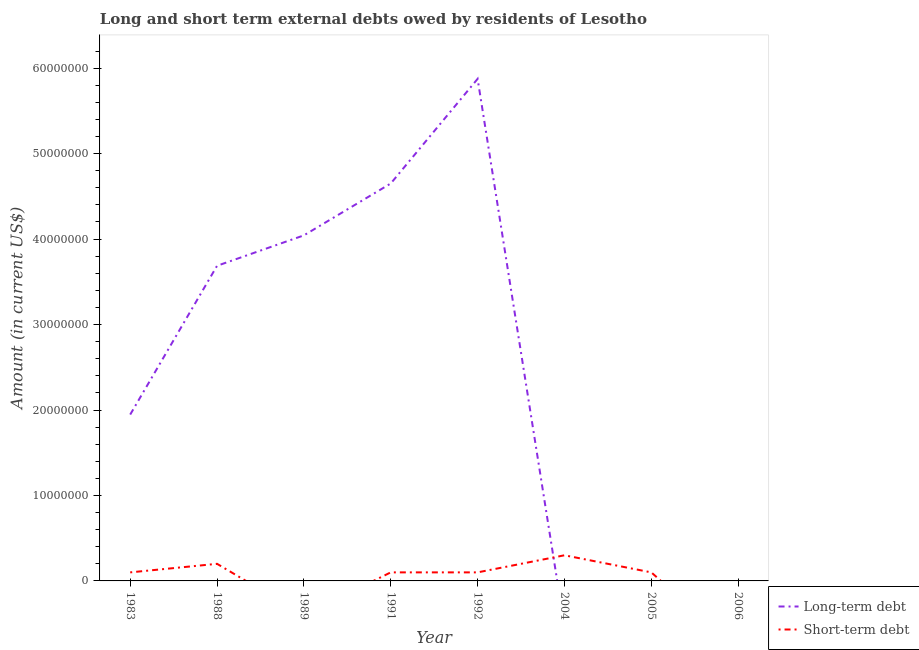How many different coloured lines are there?
Provide a succinct answer. 2. What is the short-term debts owed by residents in 1991?
Make the answer very short. 1.00e+06. Across all years, what is the maximum long-term debts owed by residents?
Your response must be concise. 5.87e+07. Across all years, what is the minimum short-term debts owed by residents?
Provide a short and direct response. 0. What is the total short-term debts owed by residents in the graph?
Ensure brevity in your answer.  9.00e+06. What is the difference between the long-term debts owed by residents in 1989 and that in 1991?
Provide a short and direct response. -6.07e+06. What is the difference between the short-term debts owed by residents in 2005 and the long-term debts owed by residents in 1992?
Keep it short and to the point. -5.77e+07. What is the average short-term debts owed by residents per year?
Your response must be concise. 1.12e+06. In the year 1991, what is the difference between the short-term debts owed by residents and long-term debts owed by residents?
Offer a very short reply. -4.55e+07. In how many years, is the long-term debts owed by residents greater than 24000000 US$?
Your answer should be compact. 4. What is the ratio of the short-term debts owed by residents in 1988 to that in 2004?
Give a very brief answer. 0.67. What is the difference between the highest and the second highest long-term debts owed by residents?
Give a very brief answer. 1.22e+07. What is the difference between the highest and the lowest short-term debts owed by residents?
Ensure brevity in your answer.  3.00e+06. In how many years, is the long-term debts owed by residents greater than the average long-term debts owed by residents taken over all years?
Give a very brief answer. 4. Is the sum of the short-term debts owed by residents in 1991 and 1992 greater than the maximum long-term debts owed by residents across all years?
Make the answer very short. No. How many lines are there?
Keep it short and to the point. 2. How many years are there in the graph?
Provide a succinct answer. 8. What is the difference between two consecutive major ticks on the Y-axis?
Your answer should be very brief. 1.00e+07. Are the values on the major ticks of Y-axis written in scientific E-notation?
Your answer should be very brief. No. Does the graph contain any zero values?
Give a very brief answer. Yes. Where does the legend appear in the graph?
Your answer should be very brief. Bottom right. How many legend labels are there?
Provide a succinct answer. 2. How are the legend labels stacked?
Give a very brief answer. Vertical. What is the title of the graph?
Make the answer very short. Long and short term external debts owed by residents of Lesotho. Does "Male entrants" appear as one of the legend labels in the graph?
Your response must be concise. No. What is the label or title of the X-axis?
Offer a terse response. Year. What is the Amount (in current US$) of Long-term debt in 1983?
Provide a succinct answer. 1.95e+07. What is the Amount (in current US$) in Long-term debt in 1988?
Ensure brevity in your answer.  3.69e+07. What is the Amount (in current US$) in Long-term debt in 1989?
Ensure brevity in your answer.  4.04e+07. What is the Amount (in current US$) in Short-term debt in 1989?
Make the answer very short. 0. What is the Amount (in current US$) in Long-term debt in 1991?
Ensure brevity in your answer.  4.65e+07. What is the Amount (in current US$) in Short-term debt in 1991?
Ensure brevity in your answer.  1.00e+06. What is the Amount (in current US$) of Long-term debt in 1992?
Give a very brief answer. 5.87e+07. What is the Amount (in current US$) in Short-term debt in 1992?
Give a very brief answer. 1.00e+06. What is the Amount (in current US$) of Long-term debt in 2004?
Provide a succinct answer. 0. What is the Amount (in current US$) of Short-term debt in 2005?
Keep it short and to the point. 1.00e+06. What is the Amount (in current US$) of Long-term debt in 2006?
Provide a short and direct response. 0. What is the Amount (in current US$) of Short-term debt in 2006?
Keep it short and to the point. 0. Across all years, what is the maximum Amount (in current US$) of Long-term debt?
Offer a terse response. 5.87e+07. Across all years, what is the minimum Amount (in current US$) in Short-term debt?
Your answer should be very brief. 0. What is the total Amount (in current US$) in Long-term debt in the graph?
Your response must be concise. 2.02e+08. What is the total Amount (in current US$) in Short-term debt in the graph?
Your response must be concise. 9.00e+06. What is the difference between the Amount (in current US$) in Long-term debt in 1983 and that in 1988?
Ensure brevity in your answer.  -1.74e+07. What is the difference between the Amount (in current US$) in Long-term debt in 1983 and that in 1989?
Your answer should be compact. -2.10e+07. What is the difference between the Amount (in current US$) in Long-term debt in 1983 and that in 1991?
Provide a short and direct response. -2.70e+07. What is the difference between the Amount (in current US$) in Long-term debt in 1983 and that in 1992?
Your answer should be compact. -3.93e+07. What is the difference between the Amount (in current US$) in Short-term debt in 1983 and that in 1992?
Offer a terse response. 0. What is the difference between the Amount (in current US$) in Short-term debt in 1983 and that in 2004?
Provide a succinct answer. -2.00e+06. What is the difference between the Amount (in current US$) of Long-term debt in 1988 and that in 1989?
Your answer should be compact. -3.56e+06. What is the difference between the Amount (in current US$) of Long-term debt in 1988 and that in 1991?
Your answer should be very brief. -9.63e+06. What is the difference between the Amount (in current US$) in Short-term debt in 1988 and that in 1991?
Offer a terse response. 1.00e+06. What is the difference between the Amount (in current US$) in Long-term debt in 1988 and that in 1992?
Make the answer very short. -2.19e+07. What is the difference between the Amount (in current US$) of Short-term debt in 1988 and that in 2005?
Your answer should be very brief. 1.00e+06. What is the difference between the Amount (in current US$) of Long-term debt in 1989 and that in 1991?
Provide a short and direct response. -6.07e+06. What is the difference between the Amount (in current US$) in Long-term debt in 1989 and that in 1992?
Keep it short and to the point. -1.83e+07. What is the difference between the Amount (in current US$) in Long-term debt in 1991 and that in 1992?
Give a very brief answer. -1.22e+07. What is the difference between the Amount (in current US$) in Short-term debt in 1991 and that in 2005?
Provide a succinct answer. 0. What is the difference between the Amount (in current US$) in Long-term debt in 1983 and the Amount (in current US$) in Short-term debt in 1988?
Offer a very short reply. 1.75e+07. What is the difference between the Amount (in current US$) in Long-term debt in 1983 and the Amount (in current US$) in Short-term debt in 1991?
Your response must be concise. 1.85e+07. What is the difference between the Amount (in current US$) of Long-term debt in 1983 and the Amount (in current US$) of Short-term debt in 1992?
Make the answer very short. 1.85e+07. What is the difference between the Amount (in current US$) of Long-term debt in 1983 and the Amount (in current US$) of Short-term debt in 2004?
Your answer should be compact. 1.65e+07. What is the difference between the Amount (in current US$) in Long-term debt in 1983 and the Amount (in current US$) in Short-term debt in 2005?
Your answer should be very brief. 1.85e+07. What is the difference between the Amount (in current US$) in Long-term debt in 1988 and the Amount (in current US$) in Short-term debt in 1991?
Offer a terse response. 3.59e+07. What is the difference between the Amount (in current US$) of Long-term debt in 1988 and the Amount (in current US$) of Short-term debt in 1992?
Your answer should be compact. 3.59e+07. What is the difference between the Amount (in current US$) in Long-term debt in 1988 and the Amount (in current US$) in Short-term debt in 2004?
Your answer should be compact. 3.39e+07. What is the difference between the Amount (in current US$) in Long-term debt in 1988 and the Amount (in current US$) in Short-term debt in 2005?
Offer a terse response. 3.59e+07. What is the difference between the Amount (in current US$) of Long-term debt in 1989 and the Amount (in current US$) of Short-term debt in 1991?
Offer a very short reply. 3.94e+07. What is the difference between the Amount (in current US$) in Long-term debt in 1989 and the Amount (in current US$) in Short-term debt in 1992?
Offer a very short reply. 3.94e+07. What is the difference between the Amount (in current US$) of Long-term debt in 1989 and the Amount (in current US$) of Short-term debt in 2004?
Provide a short and direct response. 3.74e+07. What is the difference between the Amount (in current US$) of Long-term debt in 1989 and the Amount (in current US$) of Short-term debt in 2005?
Give a very brief answer. 3.94e+07. What is the difference between the Amount (in current US$) in Long-term debt in 1991 and the Amount (in current US$) in Short-term debt in 1992?
Provide a succinct answer. 4.55e+07. What is the difference between the Amount (in current US$) of Long-term debt in 1991 and the Amount (in current US$) of Short-term debt in 2004?
Your answer should be compact. 4.35e+07. What is the difference between the Amount (in current US$) of Long-term debt in 1991 and the Amount (in current US$) of Short-term debt in 2005?
Your response must be concise. 4.55e+07. What is the difference between the Amount (in current US$) in Long-term debt in 1992 and the Amount (in current US$) in Short-term debt in 2004?
Provide a short and direct response. 5.57e+07. What is the difference between the Amount (in current US$) of Long-term debt in 1992 and the Amount (in current US$) of Short-term debt in 2005?
Offer a very short reply. 5.77e+07. What is the average Amount (in current US$) in Long-term debt per year?
Offer a terse response. 2.53e+07. What is the average Amount (in current US$) of Short-term debt per year?
Provide a short and direct response. 1.12e+06. In the year 1983, what is the difference between the Amount (in current US$) in Long-term debt and Amount (in current US$) in Short-term debt?
Provide a short and direct response. 1.85e+07. In the year 1988, what is the difference between the Amount (in current US$) in Long-term debt and Amount (in current US$) in Short-term debt?
Provide a short and direct response. 3.49e+07. In the year 1991, what is the difference between the Amount (in current US$) in Long-term debt and Amount (in current US$) in Short-term debt?
Offer a very short reply. 4.55e+07. In the year 1992, what is the difference between the Amount (in current US$) of Long-term debt and Amount (in current US$) of Short-term debt?
Provide a short and direct response. 5.77e+07. What is the ratio of the Amount (in current US$) of Long-term debt in 1983 to that in 1988?
Your answer should be very brief. 0.53. What is the ratio of the Amount (in current US$) in Long-term debt in 1983 to that in 1989?
Your response must be concise. 0.48. What is the ratio of the Amount (in current US$) of Long-term debt in 1983 to that in 1991?
Make the answer very short. 0.42. What is the ratio of the Amount (in current US$) in Long-term debt in 1983 to that in 1992?
Your answer should be compact. 0.33. What is the ratio of the Amount (in current US$) in Short-term debt in 1983 to that in 1992?
Offer a terse response. 1. What is the ratio of the Amount (in current US$) in Short-term debt in 1983 to that in 2004?
Make the answer very short. 0.33. What is the ratio of the Amount (in current US$) of Short-term debt in 1983 to that in 2005?
Your response must be concise. 1. What is the ratio of the Amount (in current US$) in Long-term debt in 1988 to that in 1989?
Offer a terse response. 0.91. What is the ratio of the Amount (in current US$) of Long-term debt in 1988 to that in 1991?
Your response must be concise. 0.79. What is the ratio of the Amount (in current US$) in Short-term debt in 1988 to that in 1991?
Offer a terse response. 2. What is the ratio of the Amount (in current US$) of Long-term debt in 1988 to that in 1992?
Your answer should be compact. 0.63. What is the ratio of the Amount (in current US$) in Short-term debt in 1988 to that in 1992?
Offer a very short reply. 2. What is the ratio of the Amount (in current US$) in Short-term debt in 1988 to that in 2005?
Your answer should be very brief. 2. What is the ratio of the Amount (in current US$) in Long-term debt in 1989 to that in 1991?
Your answer should be very brief. 0.87. What is the ratio of the Amount (in current US$) of Long-term debt in 1989 to that in 1992?
Your answer should be compact. 0.69. What is the ratio of the Amount (in current US$) of Long-term debt in 1991 to that in 1992?
Your response must be concise. 0.79. What is the ratio of the Amount (in current US$) of Short-term debt in 1991 to that in 1992?
Offer a very short reply. 1. What is the ratio of the Amount (in current US$) of Short-term debt in 1991 to that in 2005?
Make the answer very short. 1. What is the difference between the highest and the second highest Amount (in current US$) in Long-term debt?
Your answer should be very brief. 1.22e+07. What is the difference between the highest and the lowest Amount (in current US$) in Long-term debt?
Make the answer very short. 5.87e+07. What is the difference between the highest and the lowest Amount (in current US$) in Short-term debt?
Offer a very short reply. 3.00e+06. 